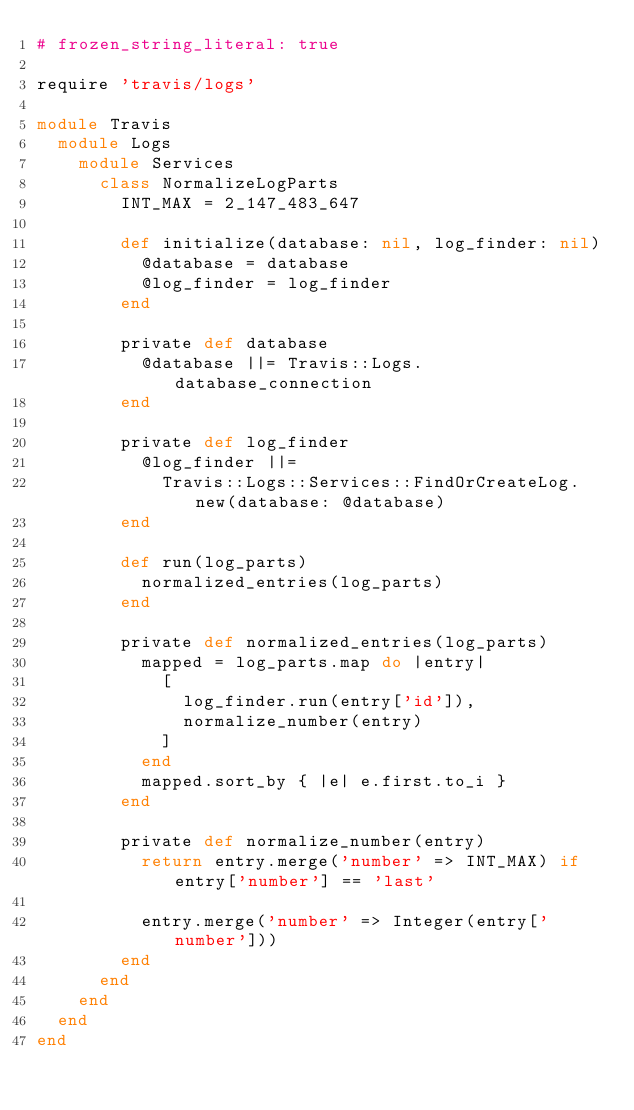Convert code to text. <code><loc_0><loc_0><loc_500><loc_500><_Ruby_># frozen_string_literal: true

require 'travis/logs'

module Travis
  module Logs
    module Services
      class NormalizeLogParts
        INT_MAX = 2_147_483_647

        def initialize(database: nil, log_finder: nil)
          @database = database
          @log_finder = log_finder
        end

        private def database
          @database ||= Travis::Logs.database_connection
        end

        private def log_finder
          @log_finder ||=
            Travis::Logs::Services::FindOrCreateLog.new(database: @database)
        end

        def run(log_parts)
          normalized_entries(log_parts)
        end

        private def normalized_entries(log_parts)
          mapped = log_parts.map do |entry|
            [
              log_finder.run(entry['id']),
              normalize_number(entry)
            ]
          end
          mapped.sort_by { |e| e.first.to_i }
        end

        private def normalize_number(entry)
          return entry.merge('number' => INT_MAX) if entry['number'] == 'last'

          entry.merge('number' => Integer(entry['number']))
        end
      end
    end
  end
end
</code> 